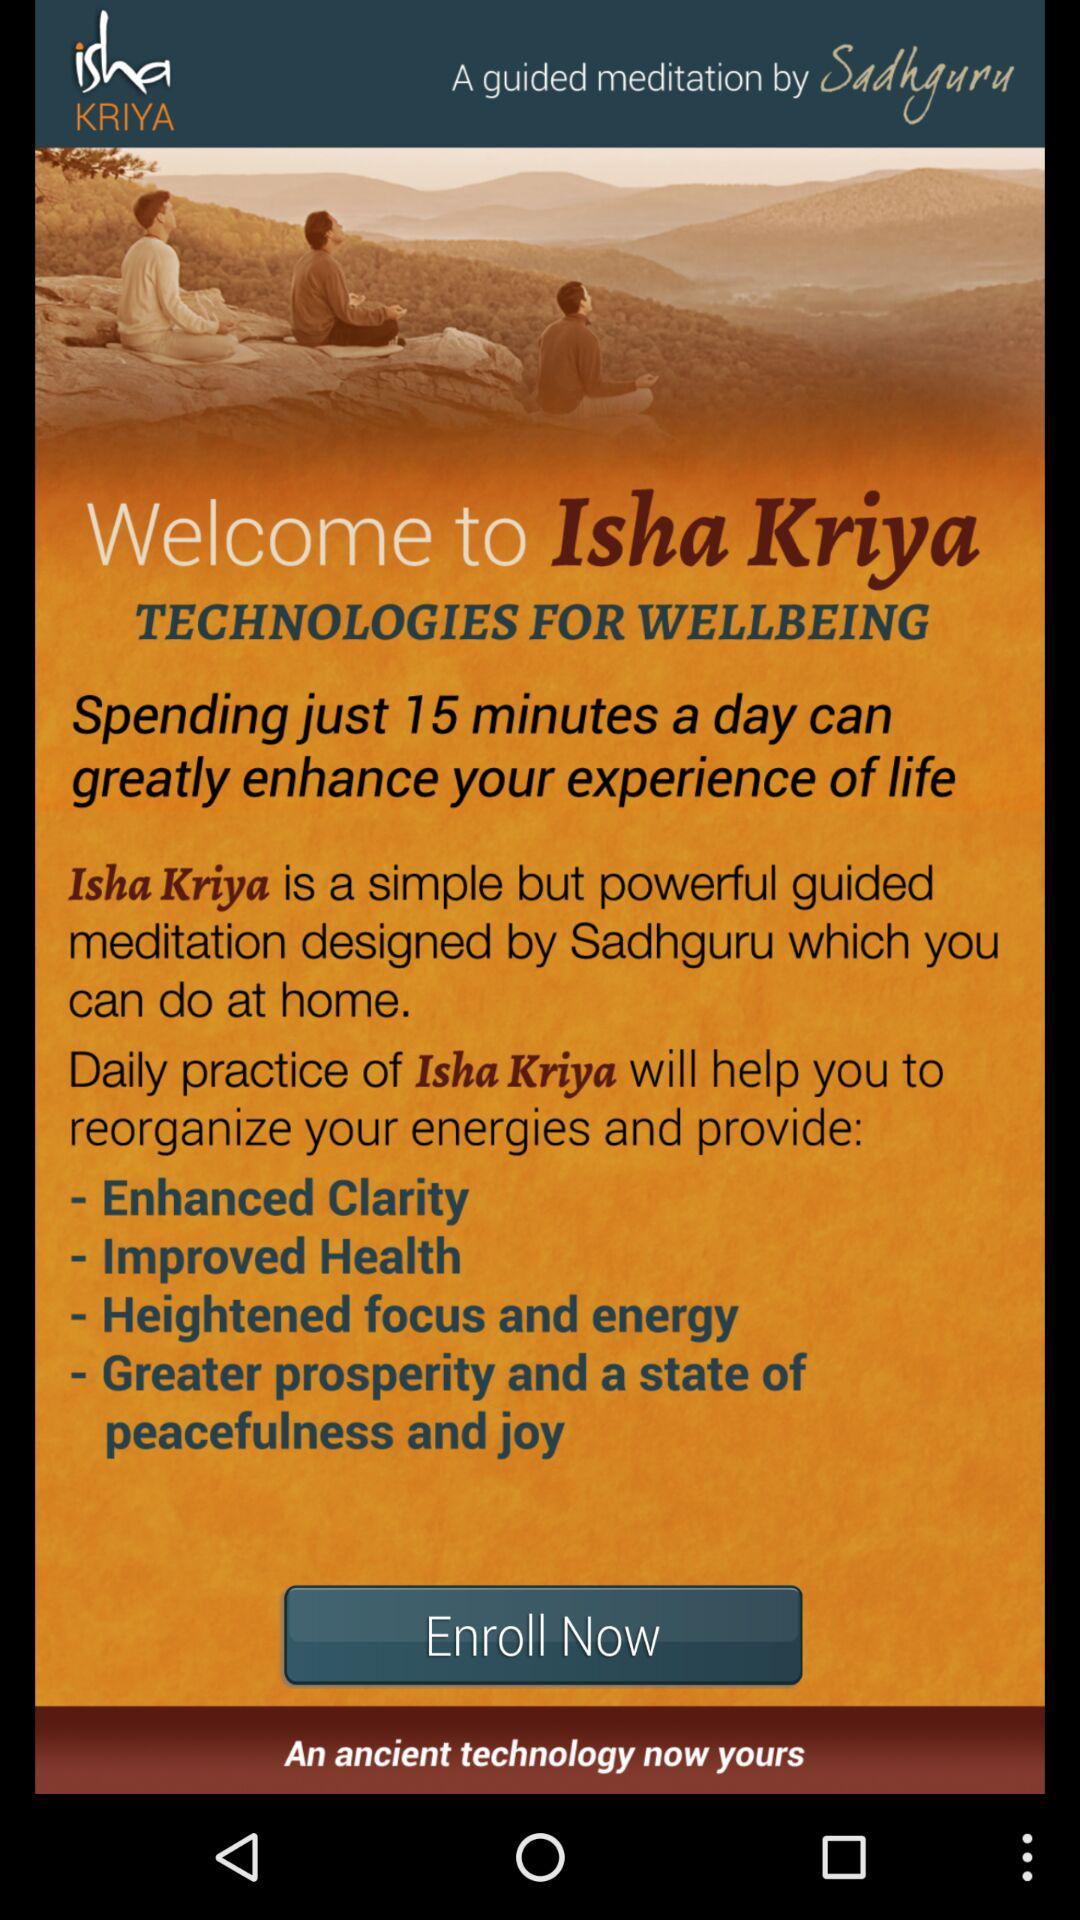What is the name of the application? The name of the application is "Isha Kriya". 